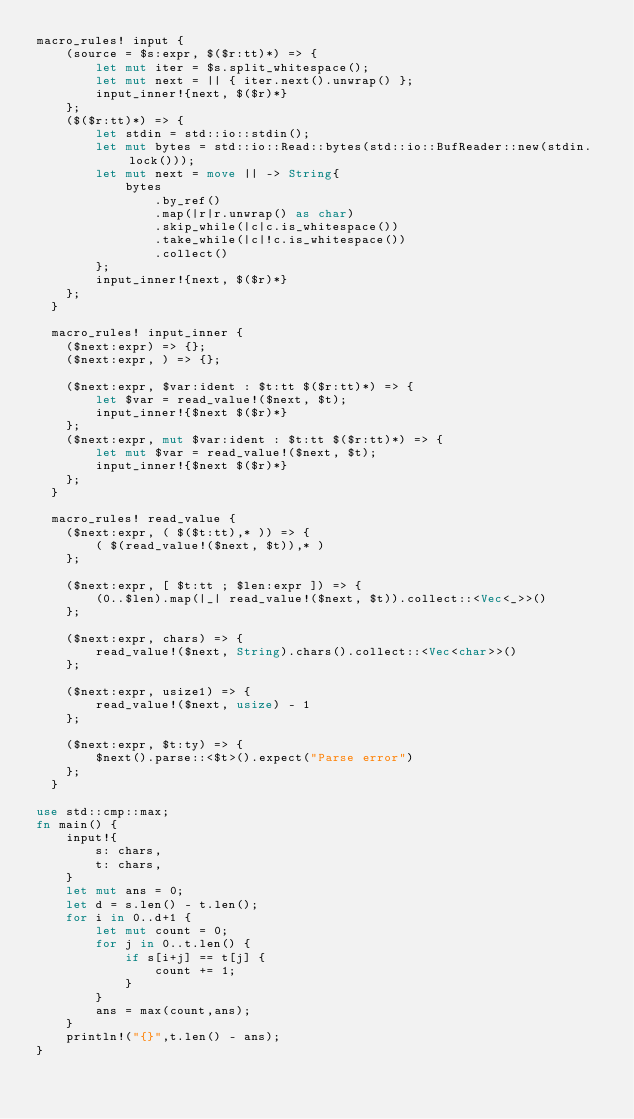<code> <loc_0><loc_0><loc_500><loc_500><_Rust_>macro_rules! input {
    (source = $s:expr, $($r:tt)*) => {
        let mut iter = $s.split_whitespace();
        let mut next = || { iter.next().unwrap() };
        input_inner!{next, $($r)*}
    };
    ($($r:tt)*) => {
        let stdin = std::io::stdin();
        let mut bytes = std::io::Read::bytes(std::io::BufReader::new(stdin.lock()));
        let mut next = move || -> String{
            bytes
                .by_ref()
                .map(|r|r.unwrap() as char)
                .skip_while(|c|c.is_whitespace())
                .take_while(|c|!c.is_whitespace())
                .collect()
        };
        input_inner!{next, $($r)*}
    };
  }
  
  macro_rules! input_inner {
    ($next:expr) => {};
    ($next:expr, ) => {};
  
    ($next:expr, $var:ident : $t:tt $($r:tt)*) => {
        let $var = read_value!($next, $t);
        input_inner!{$next $($r)*}
    };
    ($next:expr, mut $var:ident : $t:tt $($r:tt)*) => {
        let mut $var = read_value!($next, $t);
        input_inner!{$next $($r)*}
    };
  }
  
  macro_rules! read_value {
    ($next:expr, ( $($t:tt),* )) => {
        ( $(read_value!($next, $t)),* )
    };
  
    ($next:expr, [ $t:tt ; $len:expr ]) => {
        (0..$len).map(|_| read_value!($next, $t)).collect::<Vec<_>>()
    };
  
    ($next:expr, chars) => {
        read_value!($next, String).chars().collect::<Vec<char>>()
    };
  
    ($next:expr, usize1) => {
        read_value!($next, usize) - 1
    };
  
    ($next:expr, $t:ty) => {
        $next().parse::<$t>().expect("Parse error")
    };
  }

use std::cmp::max;
fn main() {
    input!{
        s: chars,
        t: chars,
    }
    let mut ans = 0;
    let d = s.len() - t.len();
    for i in 0..d+1 {
        let mut count = 0;
        for j in 0..t.len() {
            if s[i+j] == t[j] {
                count += 1;
            }
        }
        ans = max(count,ans);
    }
    println!("{}",t.len() - ans);
}</code> 